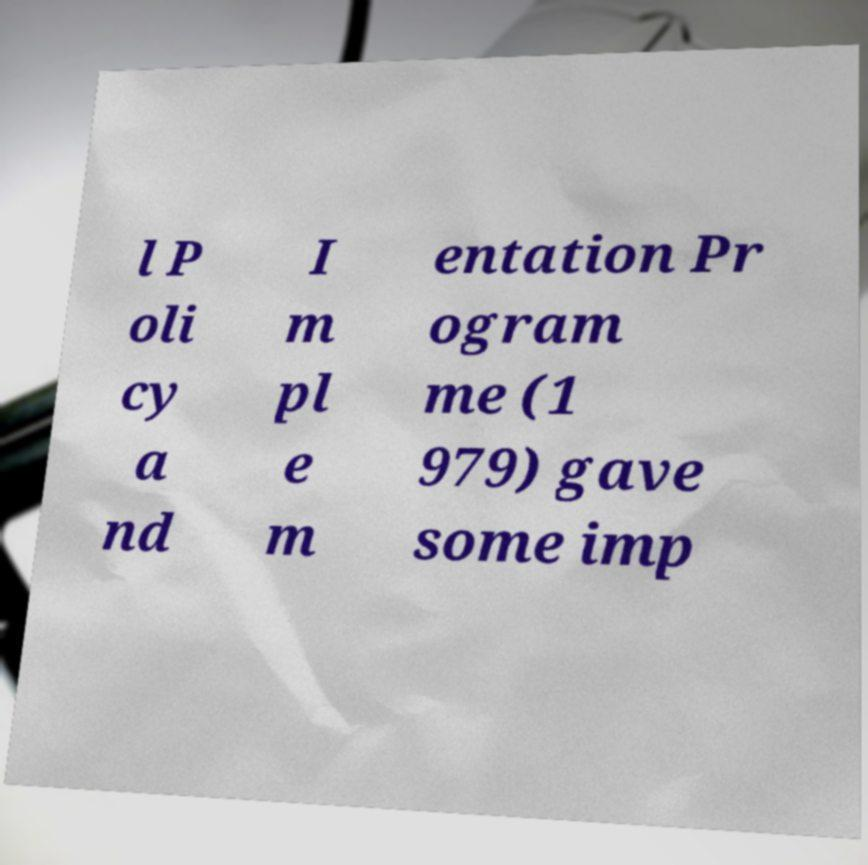Could you extract and type out the text from this image? l P oli cy a nd I m pl e m entation Pr ogram me (1 979) gave some imp 